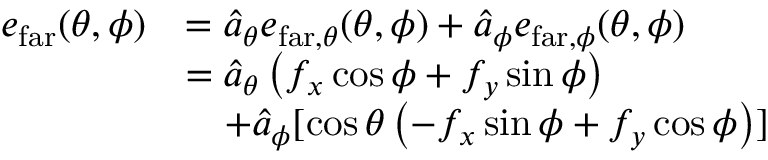Convert formula to latex. <formula><loc_0><loc_0><loc_500><loc_500>\begin{array} { r l } { e _ { f a r } ( \theta , \phi ) } & { = \hat { a } _ { \theta } e _ { f a r , \theta } ( \theta , \phi ) + \hat { a } _ { \phi } e _ { f a r , \phi } ( \theta , \phi ) } \\ & { = \hat { a } _ { \theta } \left ( f _ { x } \cos \phi + f _ { y } \sin \phi \right ) } \\ & { \quad + \hat { a } _ { \phi } [ \cos \theta \left ( - f _ { x } \sin \phi + f _ { y } \cos \phi \right ) ] } \end{array}</formula> 